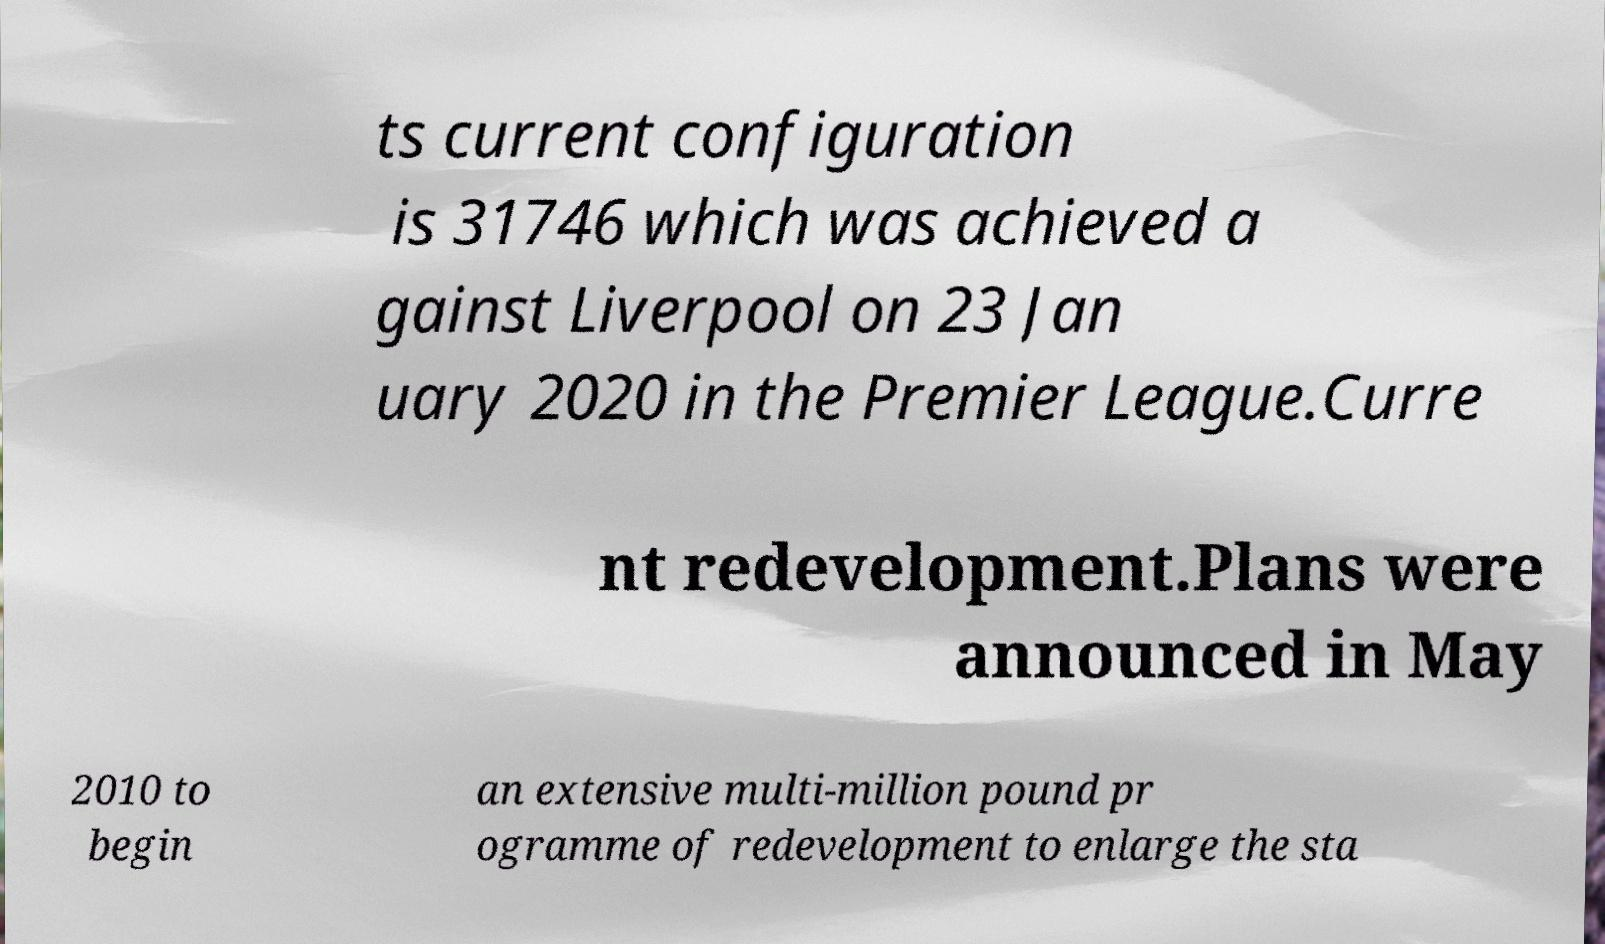Can you accurately transcribe the text from the provided image for me? ts current configuration is 31746 which was achieved a gainst Liverpool on 23 Jan uary 2020 in the Premier League.Curre nt redevelopment.Plans were announced in May 2010 to begin an extensive multi-million pound pr ogramme of redevelopment to enlarge the sta 